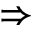Convert formula to latex. <formula><loc_0><loc_0><loc_500><loc_500>\Rightarrow</formula> 